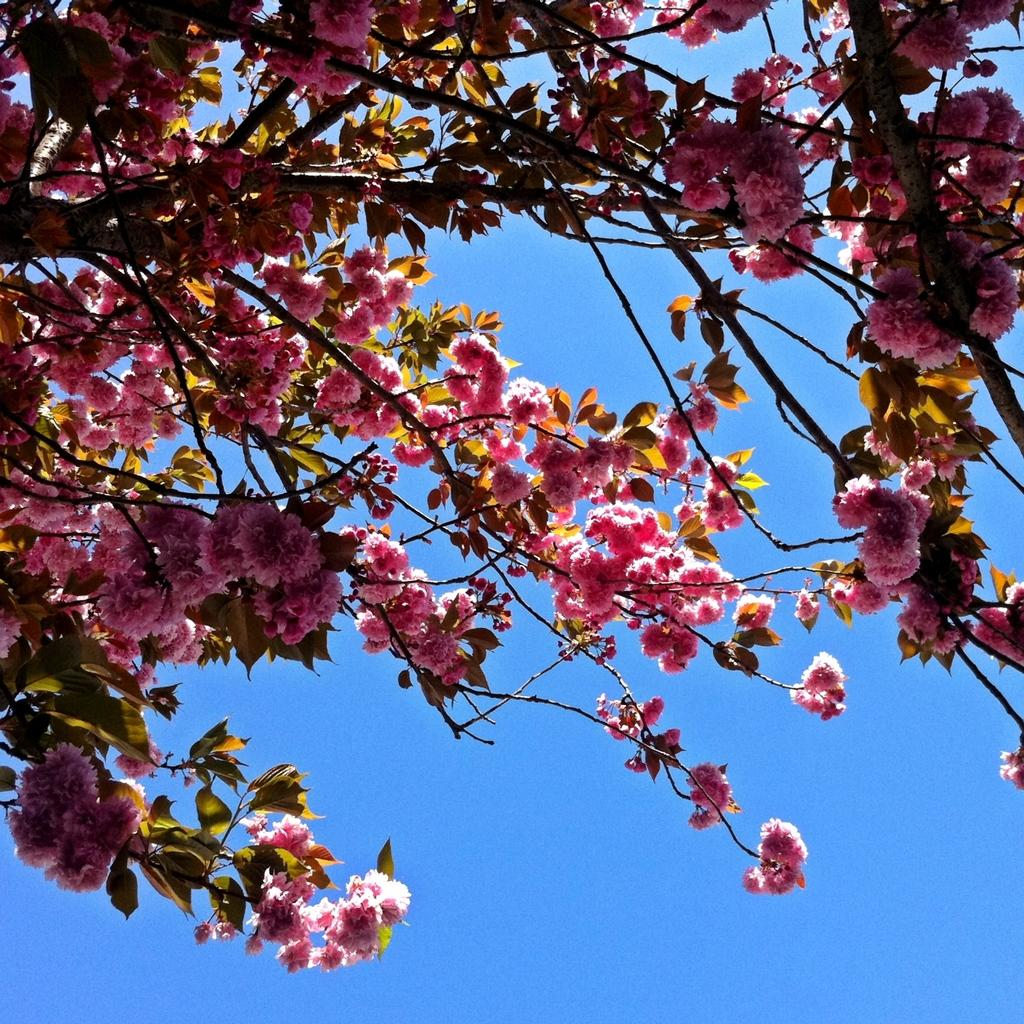What type of flowers can be seen in the image? There are blossoms in the image. What can be seen in the background of the image? There is sky visible in the background of the image. What is the reaction of the orange to the blossoms in the image? There is no orange present in the image, so it cannot react to the blossoms. 